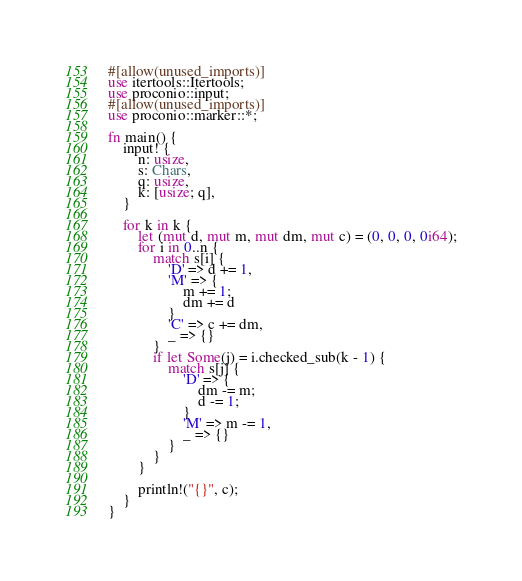Convert code to text. <code><loc_0><loc_0><loc_500><loc_500><_Rust_>#[allow(unused_imports)]
use itertools::Itertools;
use proconio::input;
#[allow(unused_imports)]
use proconio::marker::*;

fn main() {
    input! {
        n: usize,
        s: Chars,
        q: usize,
        k: [usize; q],
    }

    for k in k {
        let (mut d, mut m, mut dm, mut c) = (0, 0, 0, 0i64);
        for i in 0..n {
            match s[i] {
                'D' => d += 1,
                'M' => {
                    m += 1;
                    dm += d
                }
                'C' => c += dm,
                _ => {}
            }
            if let Some(j) = i.checked_sub(k - 1) {
                match s[j] {
                    'D' => {
                        dm -= m;
                        d -= 1;
                    }
                    'M' => m -= 1,
                    _ => {}
                }
            }
        }

        println!("{}", c);
    }
}
</code> 